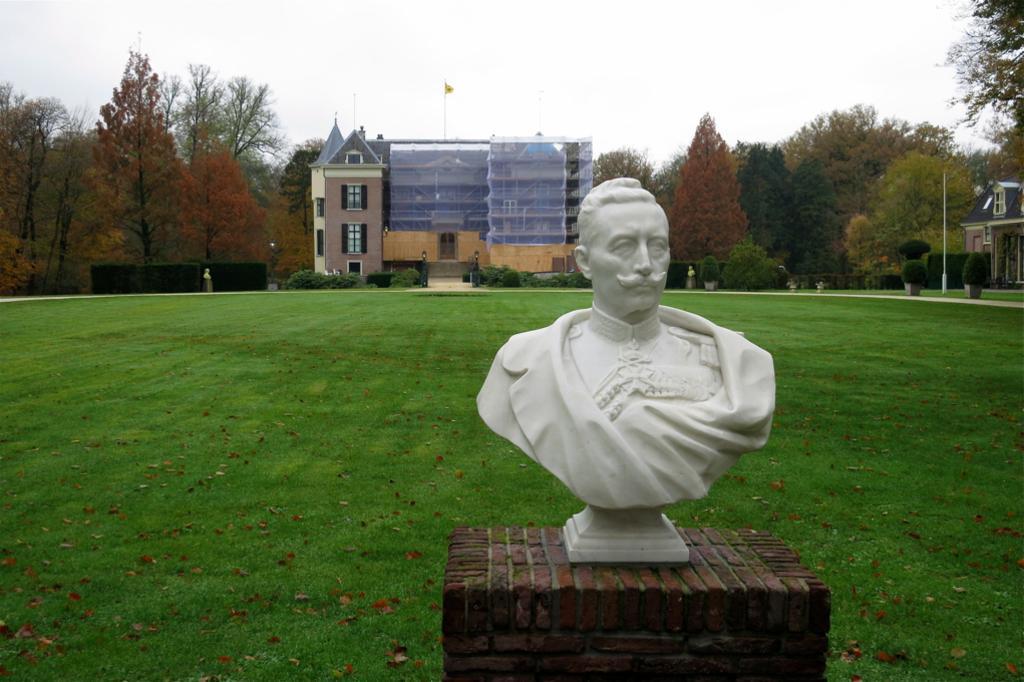Please provide a concise description of this image. In this picture we can see sculpture placed on a path, around we can see full of grass, some buildings and some trees. 